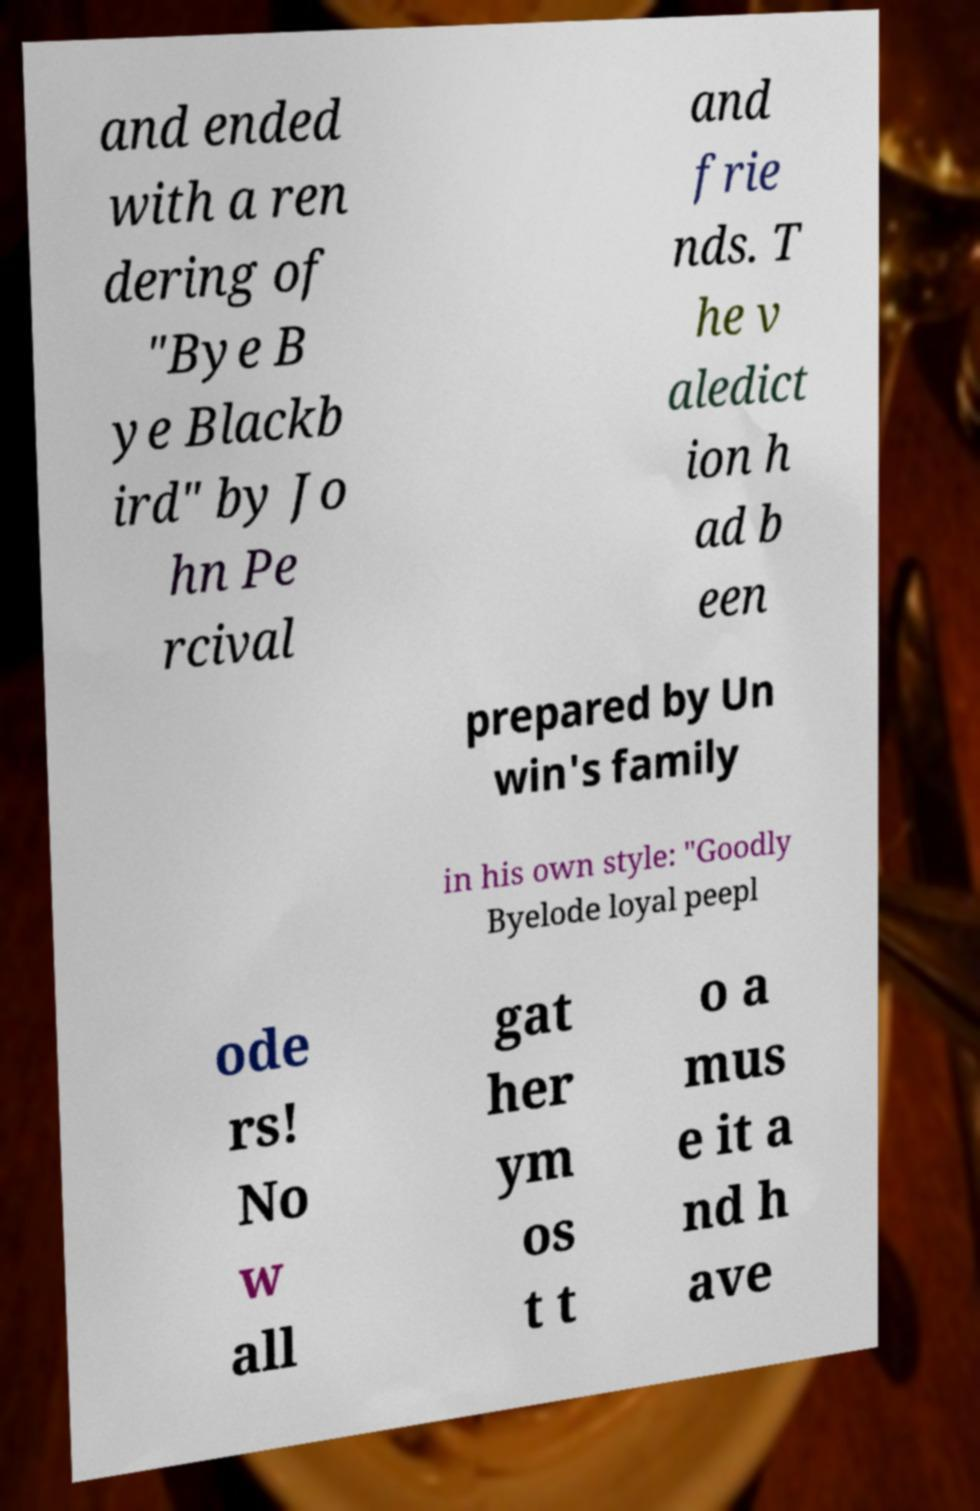Please read and relay the text visible in this image. What does it say? and ended with a ren dering of "Bye B ye Blackb ird" by Jo hn Pe rcival and frie nds. T he v aledict ion h ad b een prepared by Un win's family in his own style: "Goodly Byelode loyal peepl ode rs! No w all gat her ym os t t o a mus e it a nd h ave 